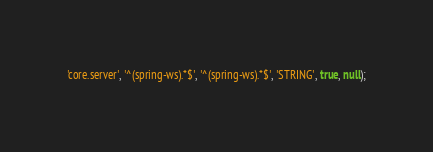<code> <loc_0><loc_0><loc_500><loc_500><_SQL_>'core.server', '^(spring-ws).*$', '^(spring-ws).*$', 'STRING', true, null);</code> 